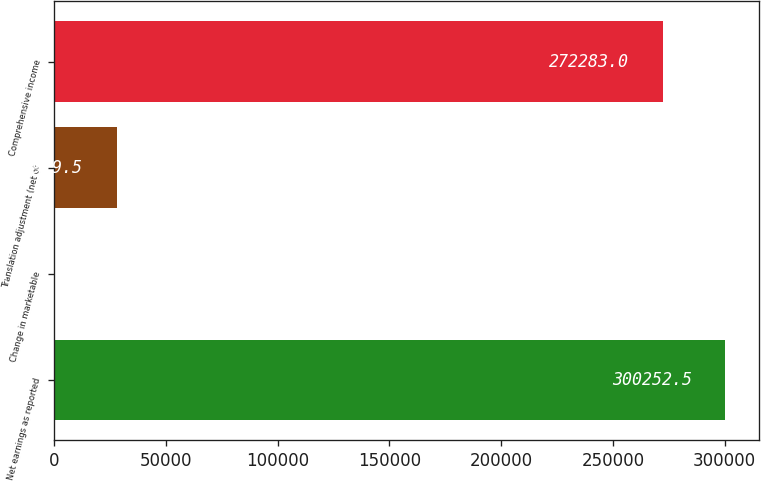Convert chart to OTSL. <chart><loc_0><loc_0><loc_500><loc_500><bar_chart><fcel>Net earnings as reported<fcel>Change in marketable<fcel>Translation adjustment (net of<fcel>Comprehensive income<nl><fcel>300252<fcel>10<fcel>27979.5<fcel>272283<nl></chart> 